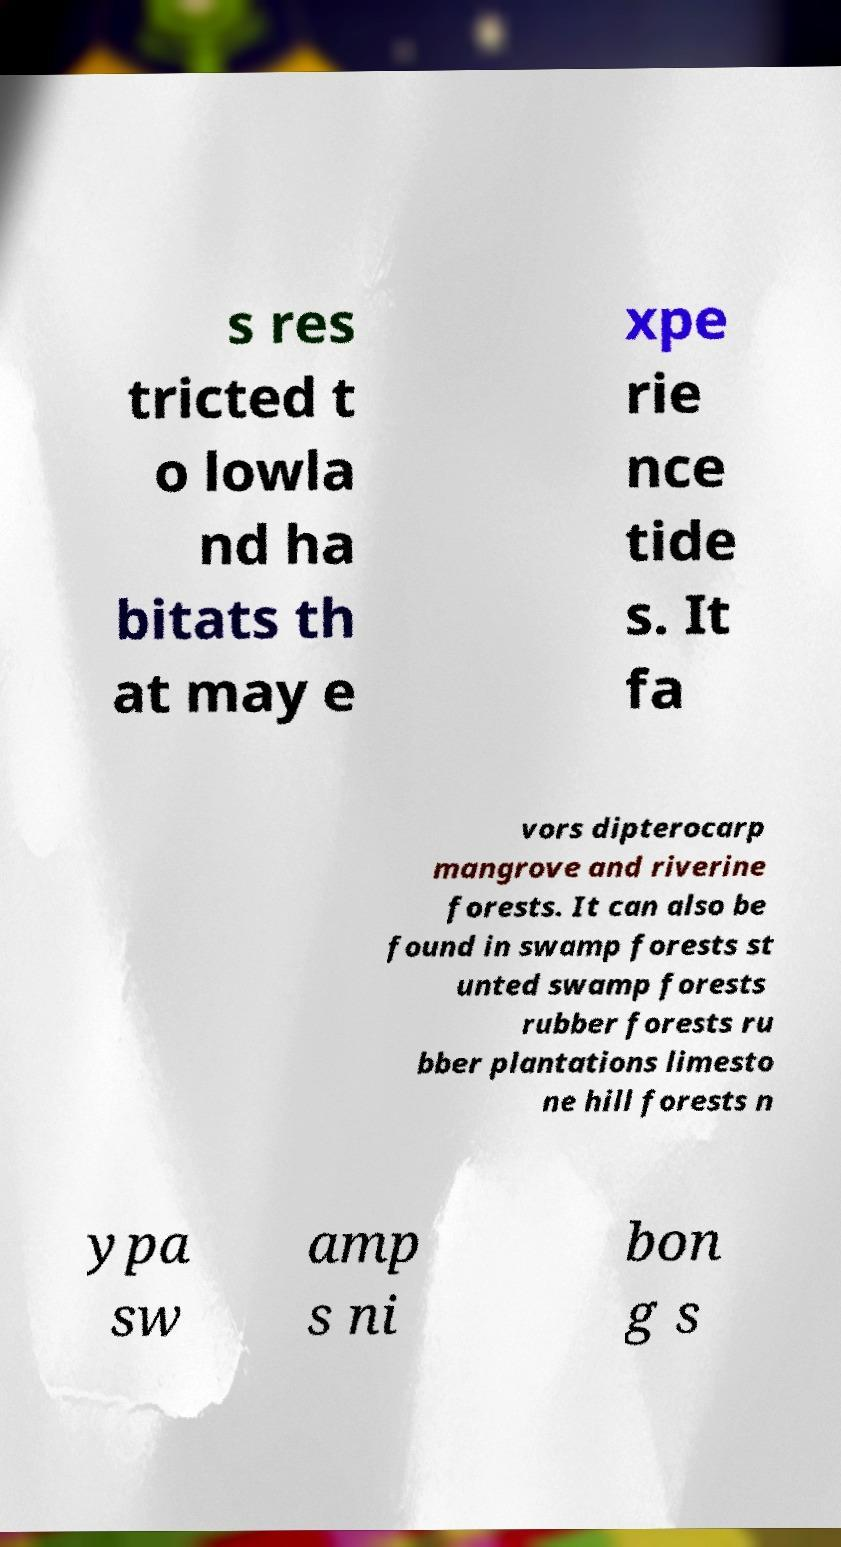Please read and relay the text visible in this image. What does it say? s res tricted t o lowla nd ha bitats th at may e xpe rie nce tide s. It fa vors dipterocarp mangrove and riverine forests. It can also be found in swamp forests st unted swamp forests rubber forests ru bber plantations limesto ne hill forests n ypa sw amp s ni bon g s 